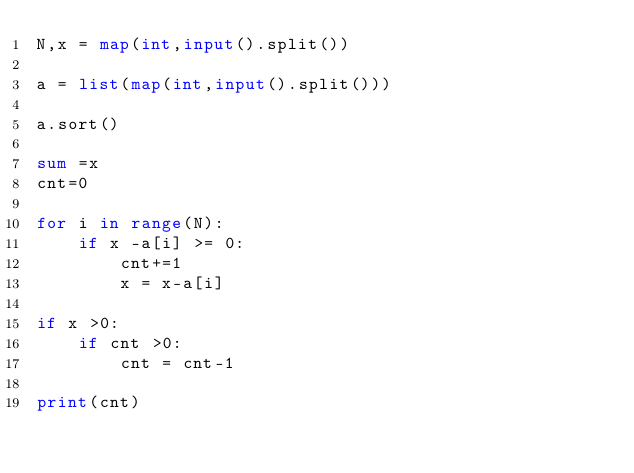Convert code to text. <code><loc_0><loc_0><loc_500><loc_500><_Python_>N,x = map(int,input().split())

a = list(map(int,input().split()))

a.sort()

sum =x
cnt=0

for i in range(N):
    if x -a[i] >= 0:
        cnt+=1
        x = x-a[i]

if x >0:
    if cnt >0:
        cnt = cnt-1
        
print(cnt)</code> 